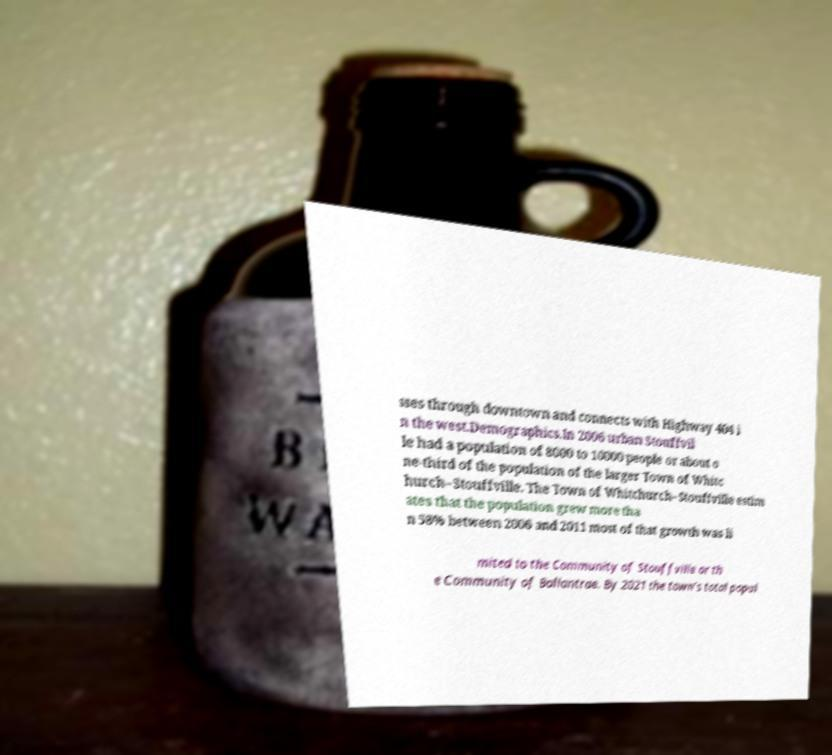Can you read and provide the text displayed in the image?This photo seems to have some interesting text. Can you extract and type it out for me? sses through downtown and connects with Highway 404 i n the west.Demographics.In 2006 urban Stouffvil le had a population of 8000 to 10000 people or about o ne-third of the population of the larger Town of Whitc hurch–Stouffville. The Town of Whitchurch–Stouffville estim ates that the population grew more tha n 58% between 2006 and 2011 most of that growth was li mited to the Community of Stouffville or th e Community of Ballantrae. By 2021 the town’s total popul 